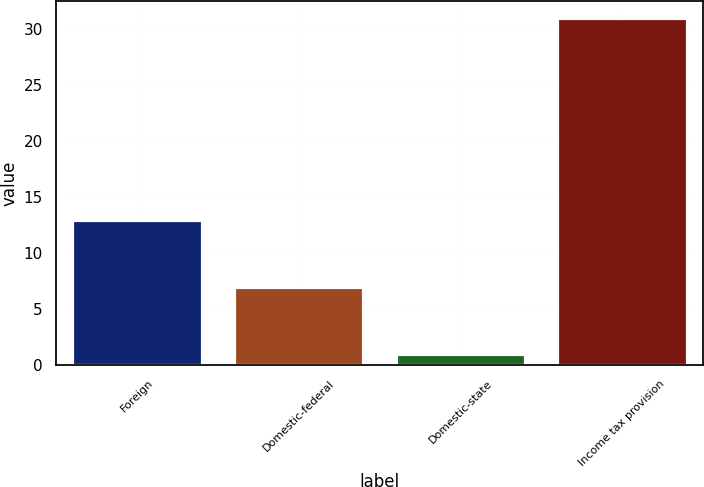Convert chart to OTSL. <chart><loc_0><loc_0><loc_500><loc_500><bar_chart><fcel>Foreign<fcel>Domestic-federal<fcel>Domestic-state<fcel>Income tax provision<nl><fcel>13<fcel>7<fcel>1<fcel>31<nl></chart> 